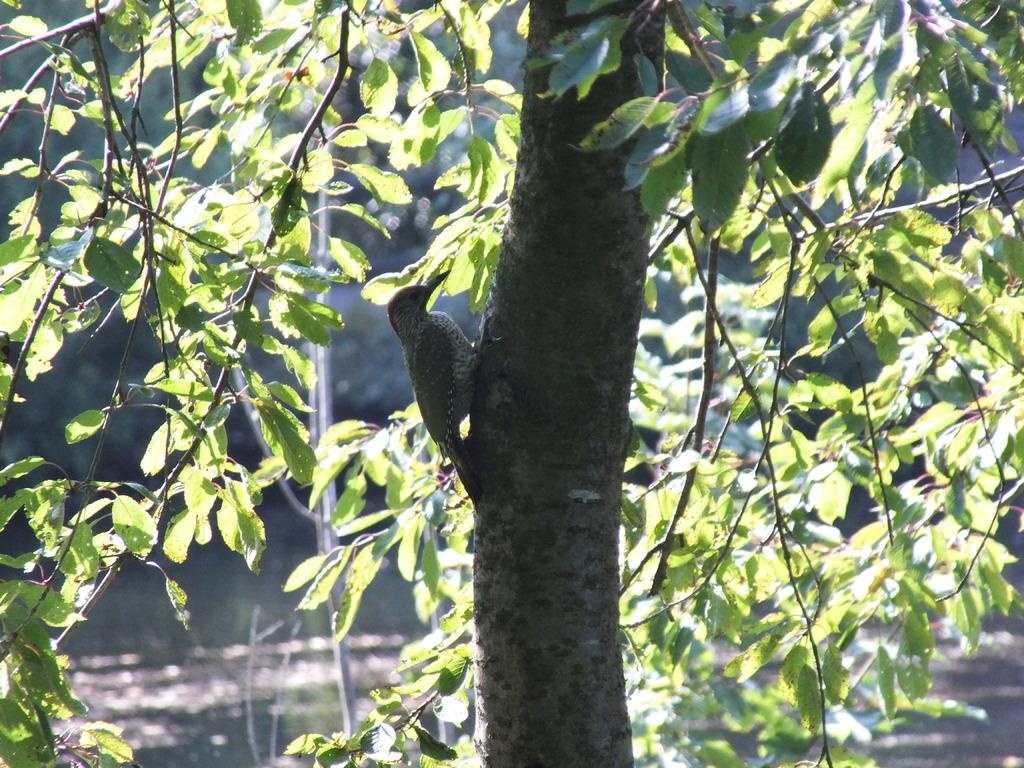What type of animal is in the image? There is a bird in the image. Where is the bird located? The bird is on a tree. What can be seen in the background of the image? There is water and additional trees visible in the background of the image. What type of polish is the bird using on its feathers in the image? There is no polish present in the image, and the bird is not using any polish on its feathers. 